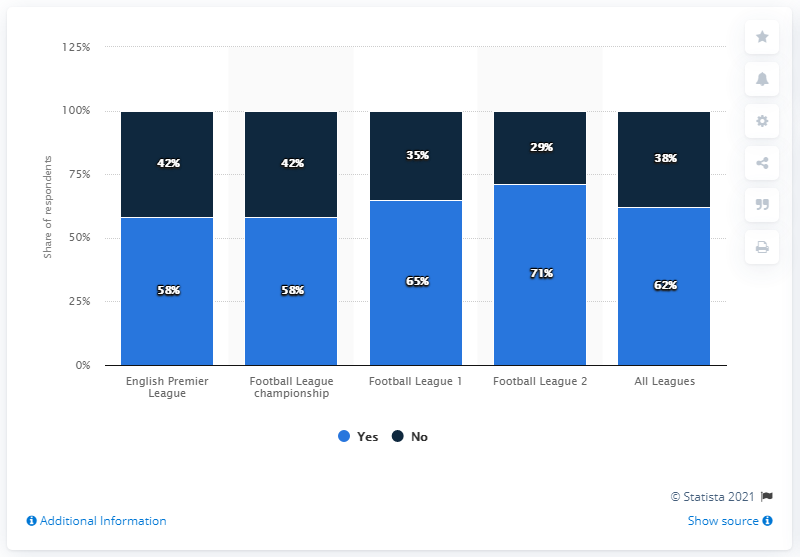List a handful of essential elements in this visual. The percentage difference between League 2 and League 4 is 42. The Football League 2 has the highest proportion of respondents, according to the survey. According to data on Premier League clubs, a significant percentage, 58%, used the profit-to-wage ratio as a key performance indicator. 